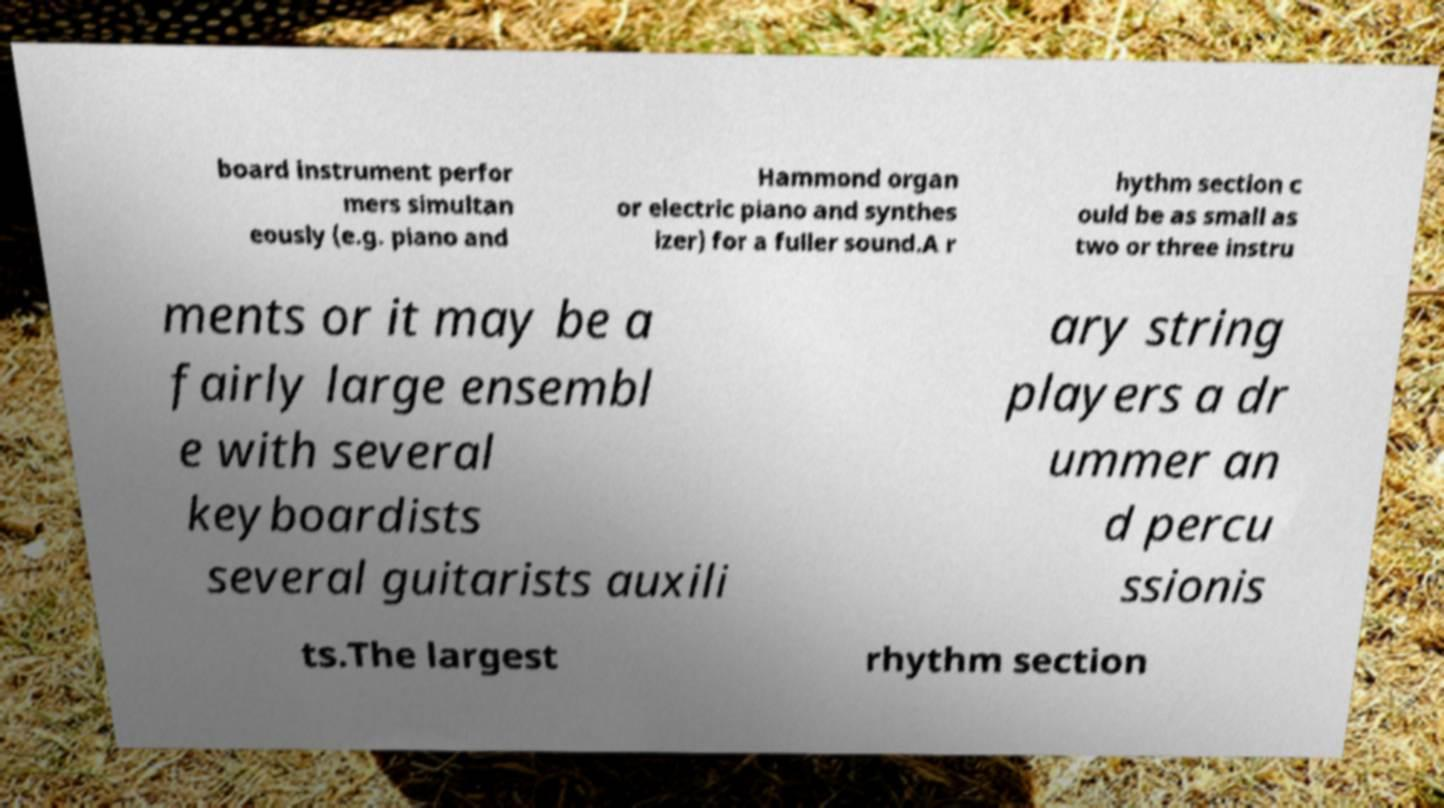For documentation purposes, I need the text within this image transcribed. Could you provide that? board instrument perfor mers simultan eously (e.g. piano and Hammond organ or electric piano and synthes izer) for a fuller sound.A r hythm section c ould be as small as two or three instru ments or it may be a fairly large ensembl e with several keyboardists several guitarists auxili ary string players a dr ummer an d percu ssionis ts.The largest rhythm section 